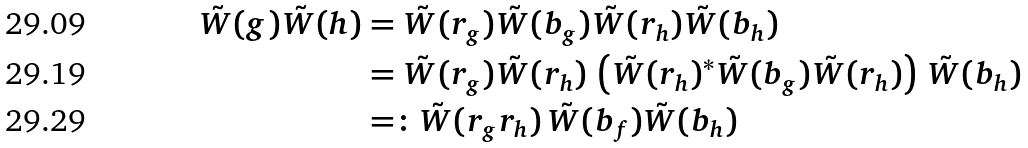<formula> <loc_0><loc_0><loc_500><loc_500>\tilde { W } ( g ) \tilde { W } ( h ) & = \tilde { W } ( r _ { g } ) \tilde { W } ( b _ { g } ) \tilde { W } ( r _ { h } ) \tilde { W } ( b _ { h } ) \\ & = \tilde { W } ( r _ { g } ) \tilde { W } ( r _ { h } ) \, \left ( \tilde { W } ( r _ { h } ) ^ { * } \tilde { W } ( b _ { g } ) \tilde { W } ( r _ { h } ) \right ) \, \tilde { W } ( b _ { h } ) \\ & = \colon \tilde { W } ( r _ { g } r _ { h } ) \, \tilde { W } ( b _ { f } ) \tilde { W } ( b _ { h } )</formula> 